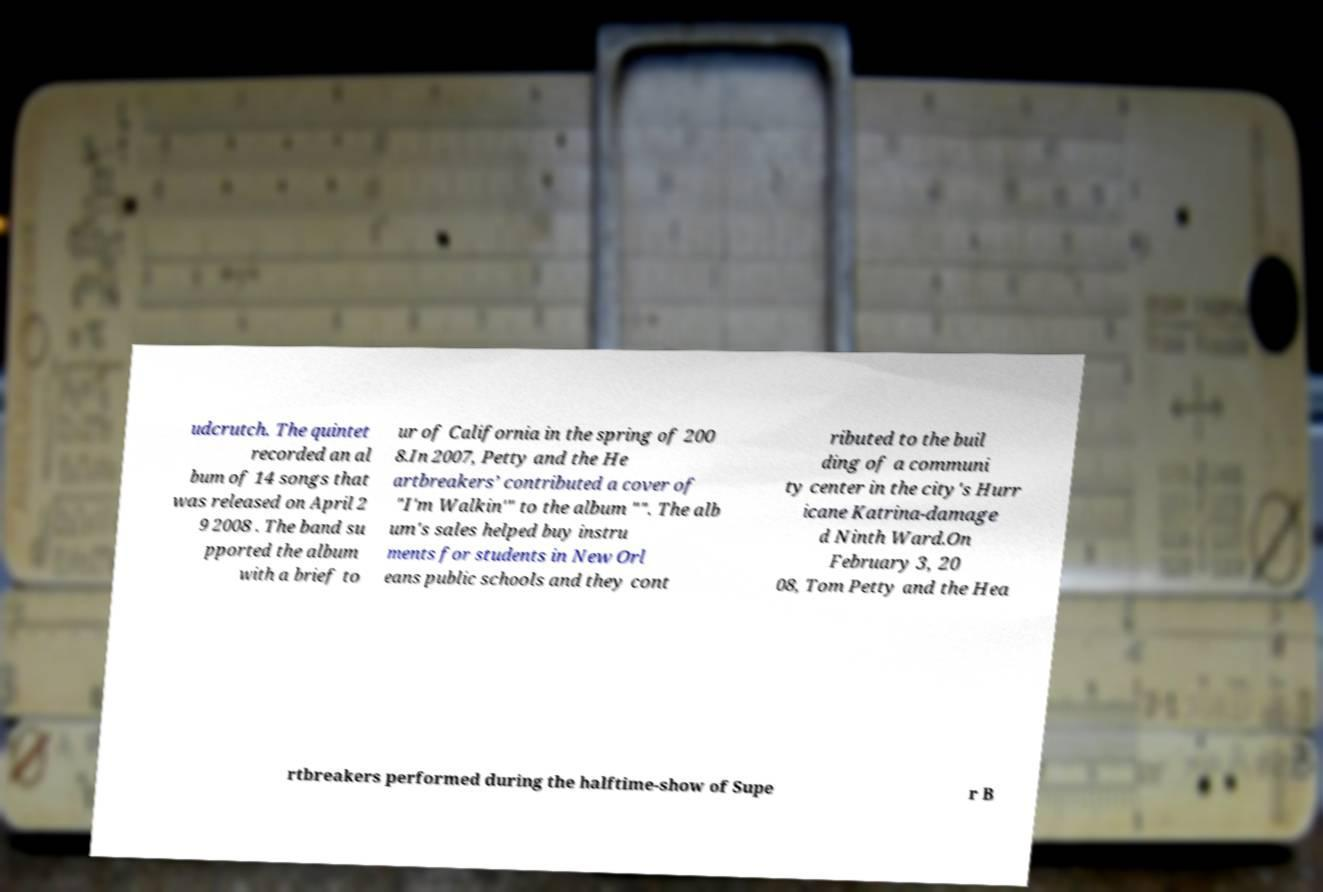I need the written content from this picture converted into text. Can you do that? udcrutch. The quintet recorded an al bum of 14 songs that was released on April 2 9 2008 . The band su pported the album with a brief to ur of California in the spring of 200 8.In 2007, Petty and the He artbreakers’ contributed a cover of "I'm Walkin'" to the album "". The alb um's sales helped buy instru ments for students in New Orl eans public schools and they cont ributed to the buil ding of a communi ty center in the city's Hurr icane Katrina-damage d Ninth Ward.On February 3, 20 08, Tom Petty and the Hea rtbreakers performed during the halftime-show of Supe r B 